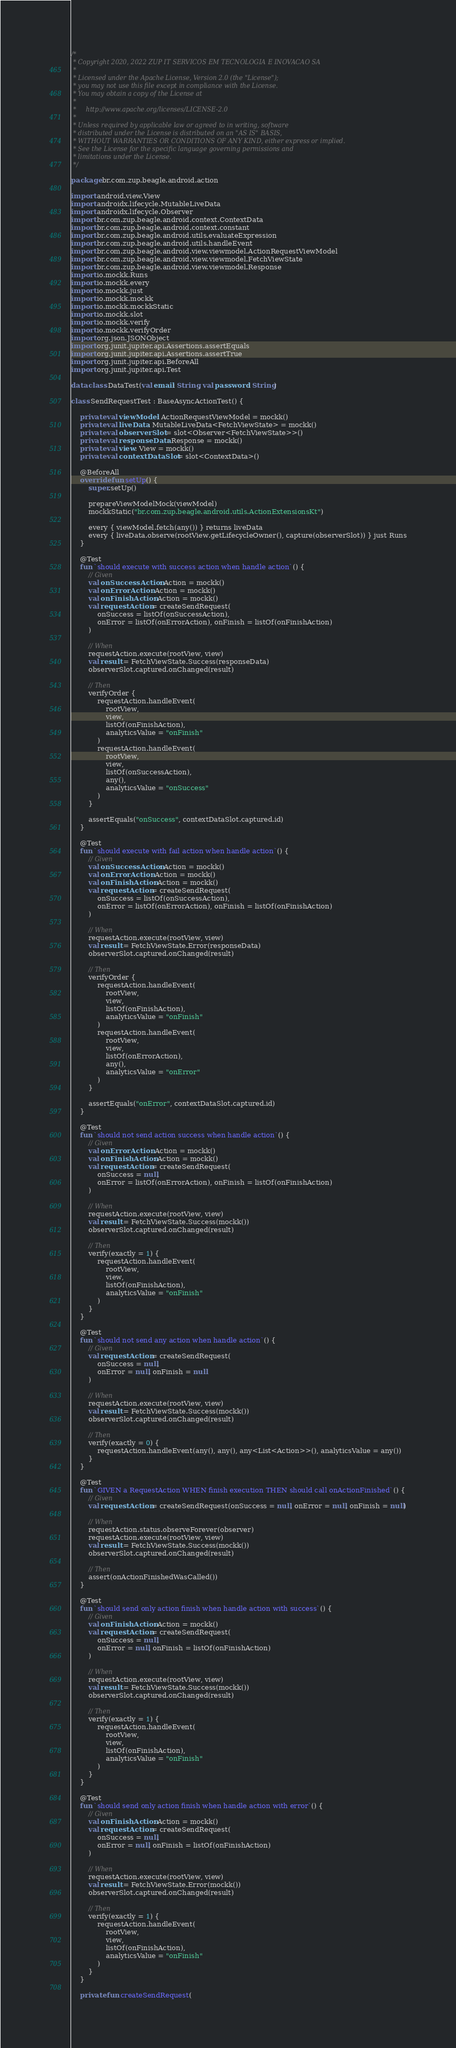Convert code to text. <code><loc_0><loc_0><loc_500><loc_500><_Kotlin_>/*
 * Copyright 2020, 2022 ZUP IT SERVICOS EM TECNOLOGIA E INOVACAO SA
 *
 * Licensed under the Apache License, Version 2.0 (the "License");
 * you may not use this file except in compliance with the License.
 * You may obtain a copy of the License at
 *
 *     http://www.apache.org/licenses/LICENSE-2.0
 *
 * Unless required by applicable law or agreed to in writing, software
 * distributed under the License is distributed on an "AS IS" BASIS,
 * WITHOUT WARRANTIES OR CONDITIONS OF ANY KIND, either express or implied.
 * See the License for the specific language governing permissions and
 * limitations under the License.
 */

package br.com.zup.beagle.android.action

import android.view.View
import androidx.lifecycle.MutableLiveData
import androidx.lifecycle.Observer
import br.com.zup.beagle.android.context.ContextData
import br.com.zup.beagle.android.context.constant
import br.com.zup.beagle.android.utils.evaluateExpression
import br.com.zup.beagle.android.utils.handleEvent
import br.com.zup.beagle.android.view.viewmodel.ActionRequestViewModel
import br.com.zup.beagle.android.view.viewmodel.FetchViewState
import br.com.zup.beagle.android.view.viewmodel.Response
import io.mockk.Runs
import io.mockk.every
import io.mockk.just
import io.mockk.mockk
import io.mockk.mockkStatic
import io.mockk.slot
import io.mockk.verify
import io.mockk.verifyOrder
import org.json.JSONObject
import org.junit.jupiter.api.Assertions.assertEquals
import org.junit.jupiter.api.Assertions.assertTrue
import org.junit.jupiter.api.BeforeAll
import org.junit.jupiter.api.Test

data class DataTest(val email: String, val password: String)

class SendRequestTest : BaseAsyncActionTest() {

    private val viewModel: ActionRequestViewModel = mockk()
    private val liveData: MutableLiveData<FetchViewState> = mockk()
    private val observerSlot = slot<Observer<FetchViewState>>()
    private val responseData: Response = mockk()
    private val view: View = mockk()
    private val contextDataSlot = slot<ContextData>()

    @BeforeAll
    override fun setUp() {
        super.setUp()

        prepareViewModelMock(viewModel)
        mockkStatic("br.com.zup.beagle.android.utils.ActionExtensionsKt")

        every { viewModel.fetch(any()) } returns liveData
        every { liveData.observe(rootView.getLifecycleOwner(), capture(observerSlot)) } just Runs
    }

    @Test
    fun `should execute with success action when handle action`() {
        // Given
        val onSuccessAction: Action = mockk()
        val onErrorAction: Action = mockk()
        val onFinishAction: Action = mockk()
        val requestAction = createSendRequest(
            onSuccess = listOf(onSuccessAction),
            onError = listOf(onErrorAction), onFinish = listOf(onFinishAction)
        )

        // When
        requestAction.execute(rootView, view)
        val result = FetchViewState.Success(responseData)
        observerSlot.captured.onChanged(result)

        // Then
        verifyOrder {
            requestAction.handleEvent(
                rootView,
                view,
                listOf(onFinishAction),
                analyticsValue = "onFinish"
            )
            requestAction.handleEvent(
                rootView,
                view,
                listOf(onSuccessAction),
                any(),
                analyticsValue = "onSuccess"
            )
        }

        assertEquals("onSuccess", contextDataSlot.captured.id)
    }

    @Test
    fun `should execute with fail action when handle action`() {
        // Given
        val onSuccessAction: Action = mockk()
        val onErrorAction: Action = mockk()
        val onFinishAction: Action = mockk()
        val requestAction = createSendRequest(
            onSuccess = listOf(onSuccessAction),
            onError = listOf(onErrorAction), onFinish = listOf(onFinishAction)
        )

        // When
        requestAction.execute(rootView, view)
        val result = FetchViewState.Error(responseData)
        observerSlot.captured.onChanged(result)

        // Then
        verifyOrder {
            requestAction.handleEvent(
                rootView,
                view,
                listOf(onFinishAction),
                analyticsValue = "onFinish"
            )
            requestAction.handleEvent(
                rootView,
                view,
                listOf(onErrorAction),
                any(),
                analyticsValue = "onError"
            )
        }

        assertEquals("onError", contextDataSlot.captured.id)
    }

    @Test
    fun `should not send action success when handle action`() {
        // Given
        val onErrorAction: Action = mockk()
        val onFinishAction: Action = mockk()
        val requestAction = createSendRequest(
            onSuccess = null,
            onError = listOf(onErrorAction), onFinish = listOf(onFinishAction)
        )

        // When
        requestAction.execute(rootView, view)
        val result = FetchViewState.Success(mockk())
        observerSlot.captured.onChanged(result)

        // Then
        verify(exactly = 1) {
            requestAction.handleEvent(
                rootView,
                view,
                listOf(onFinishAction),
                analyticsValue = "onFinish"
            )
        }
    }

    @Test
    fun `should not send any action when handle action`() {
        // Given
        val requestAction = createSendRequest(
            onSuccess = null,
            onError = null, onFinish = null
        )

        // When
        requestAction.execute(rootView, view)
        val result = FetchViewState.Success(mockk())
        observerSlot.captured.onChanged(result)

        // Then
        verify(exactly = 0) {
            requestAction.handleEvent(any(), any(), any<List<Action>>(), analyticsValue = any())
        }
    }

    @Test
    fun `GIVEN a RequestAction WHEN finish execution THEN should call onActionFinished`() {
        // Given
        val requestAction = createSendRequest(onSuccess = null, onError = null, onFinish = null)

        // When
        requestAction.status.observeForever(observer)
        requestAction.execute(rootView, view)
        val result = FetchViewState.Success(mockk())
        observerSlot.captured.onChanged(result)

        // Then
        assert(onActionFinishedWasCalled())
    }

    @Test
    fun `should send only action finish when handle action with success`() {
        // Given
        val onFinishAction: Action = mockk()
        val requestAction = createSendRequest(
            onSuccess = null,
            onError = null, onFinish = listOf(onFinishAction)
        )

        // When
        requestAction.execute(rootView, view)
        val result = FetchViewState.Success(mockk())
        observerSlot.captured.onChanged(result)

        // Then
        verify(exactly = 1) {
            requestAction.handleEvent(
                rootView,
                view,
                listOf(onFinishAction),
                analyticsValue = "onFinish"
            )
        }
    }

    @Test
    fun `should send only action finish when handle action with error`() {
        // Given
        val onFinishAction: Action = mockk()
        val requestAction = createSendRequest(
            onSuccess = null,
            onError = null, onFinish = listOf(onFinishAction)
        )

        // When
        requestAction.execute(rootView, view)
        val result = FetchViewState.Error(mockk())
        observerSlot.captured.onChanged(result)

        // Then
        verify(exactly = 1) {
            requestAction.handleEvent(
                rootView,
                view,
                listOf(onFinishAction),
                analyticsValue = "onFinish"
            )
        }
    }

    private fun createSendRequest(</code> 